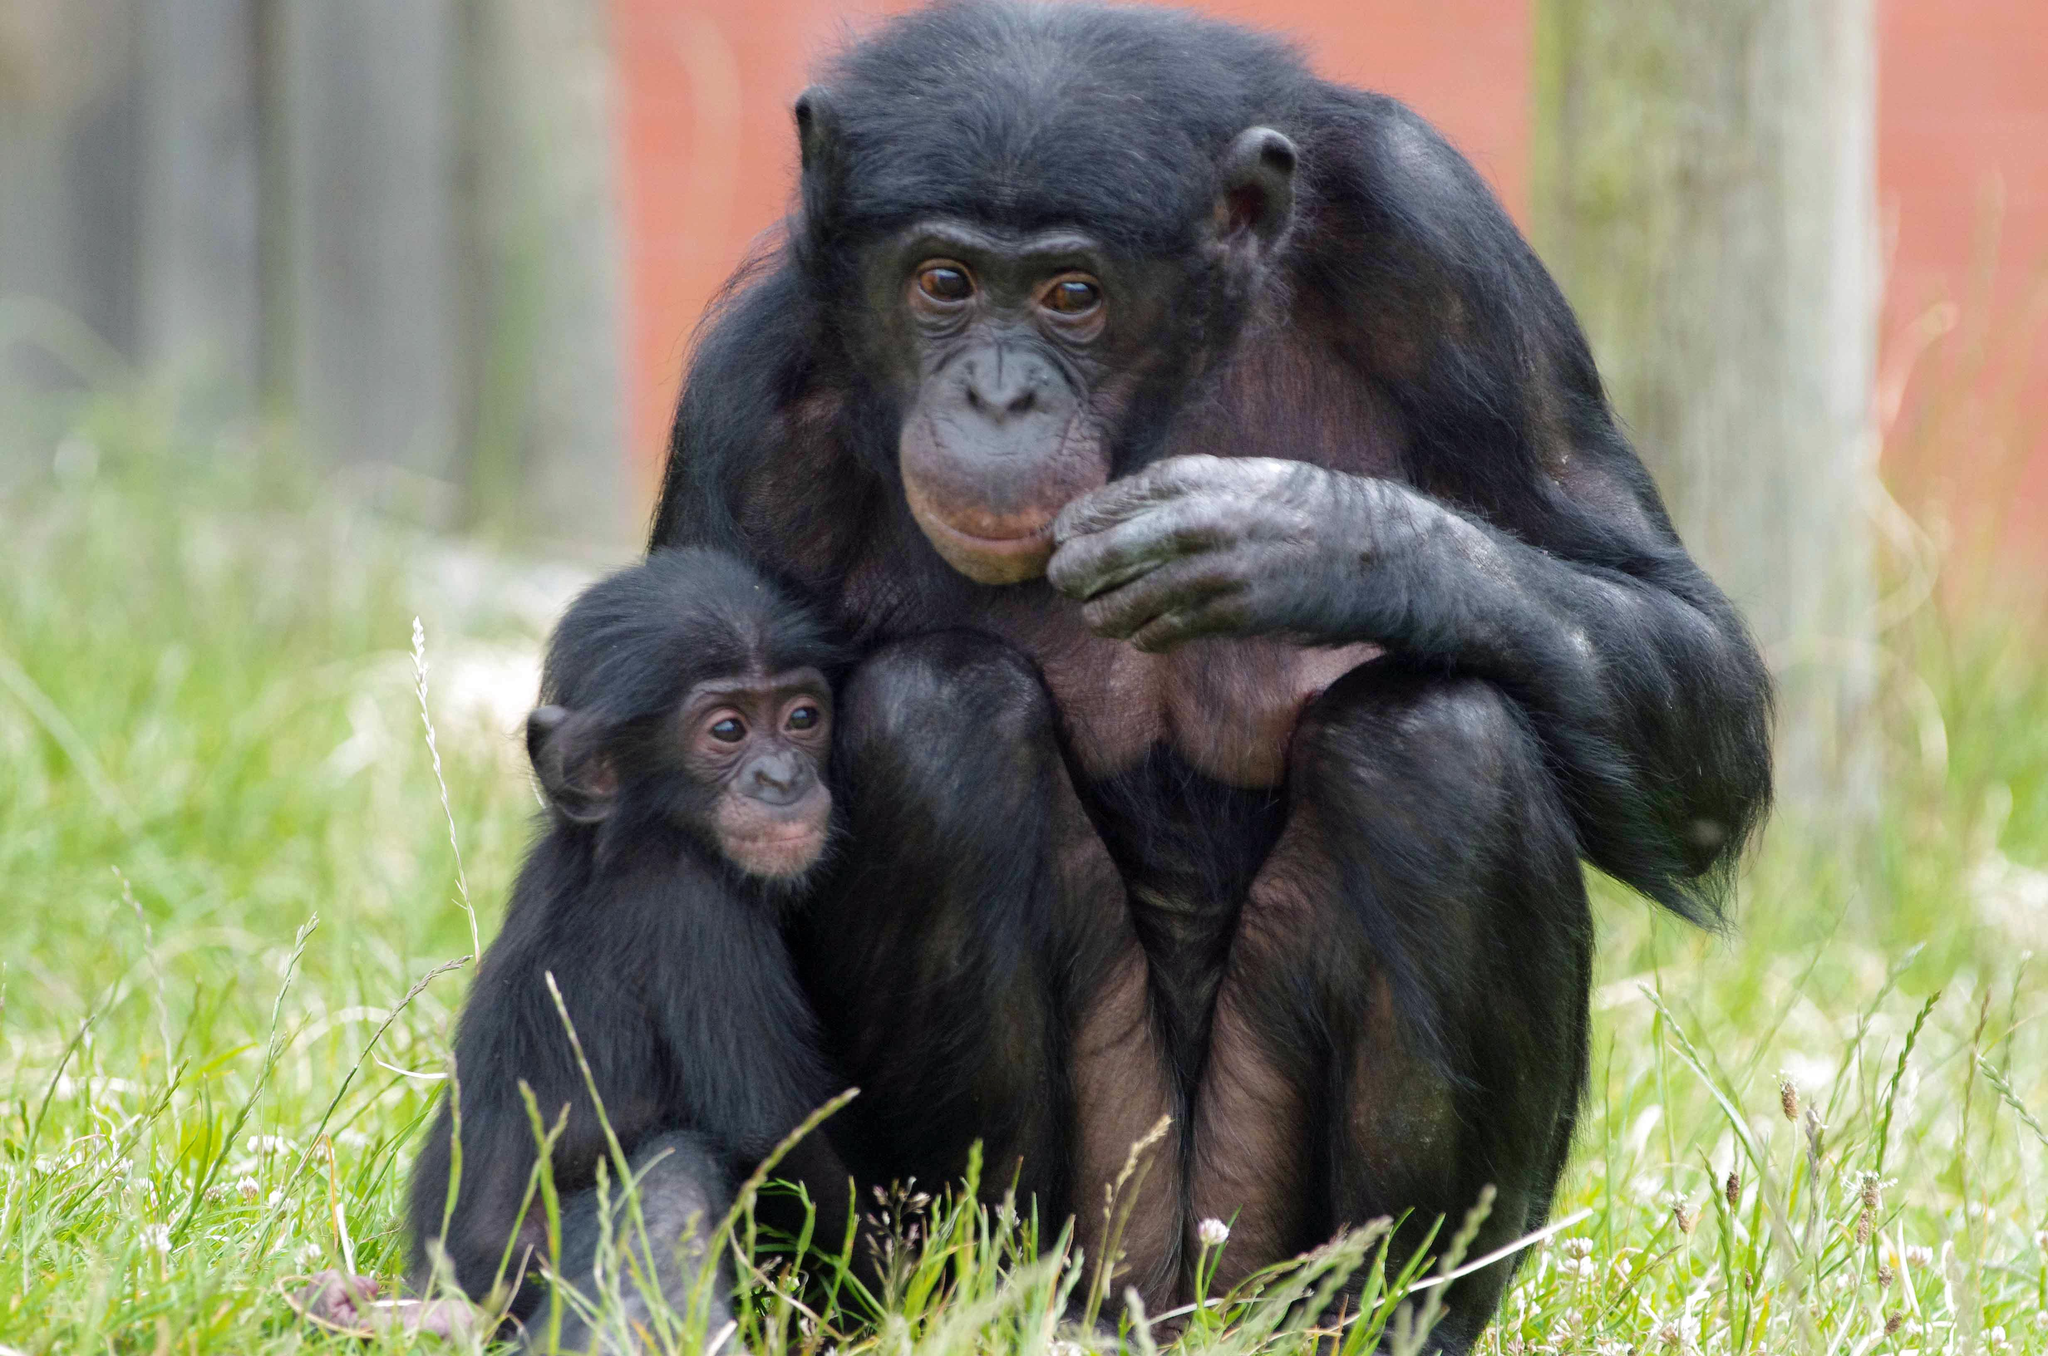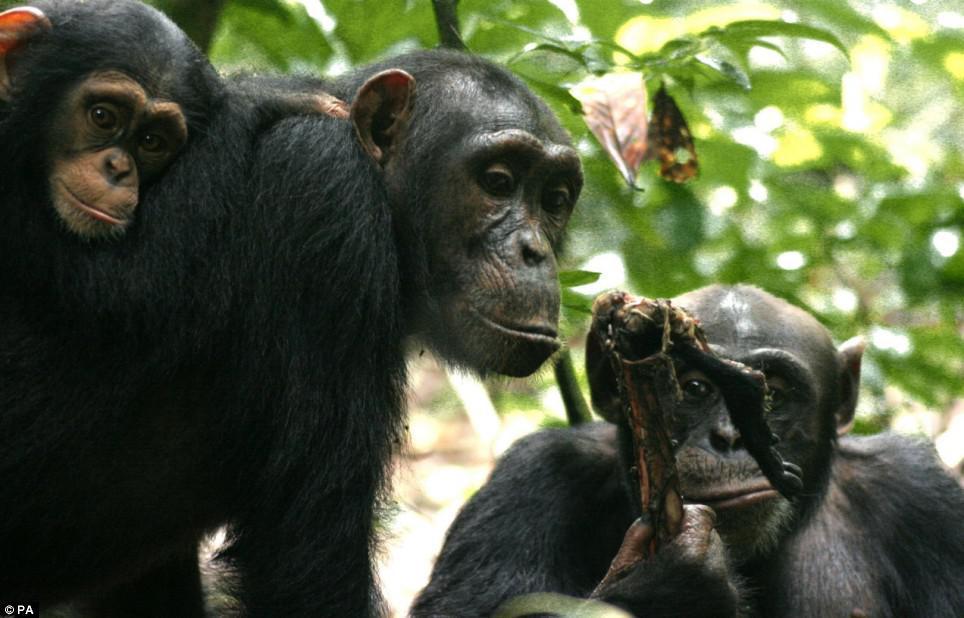The first image is the image on the left, the second image is the image on the right. Given the left and right images, does the statement "Atleast one image shows exactly two chimps sitting in the grass." hold true? Answer yes or no. Yes. 